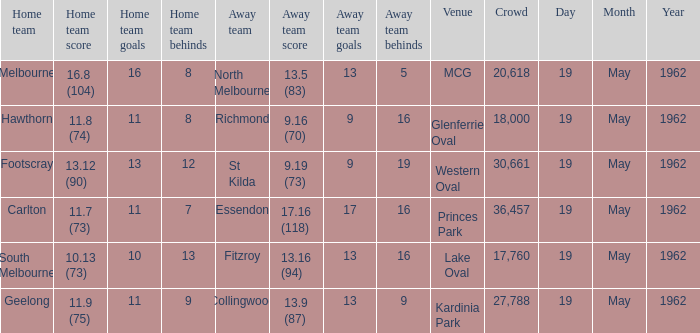What day is the venue the western oval? 19 May 1962. 